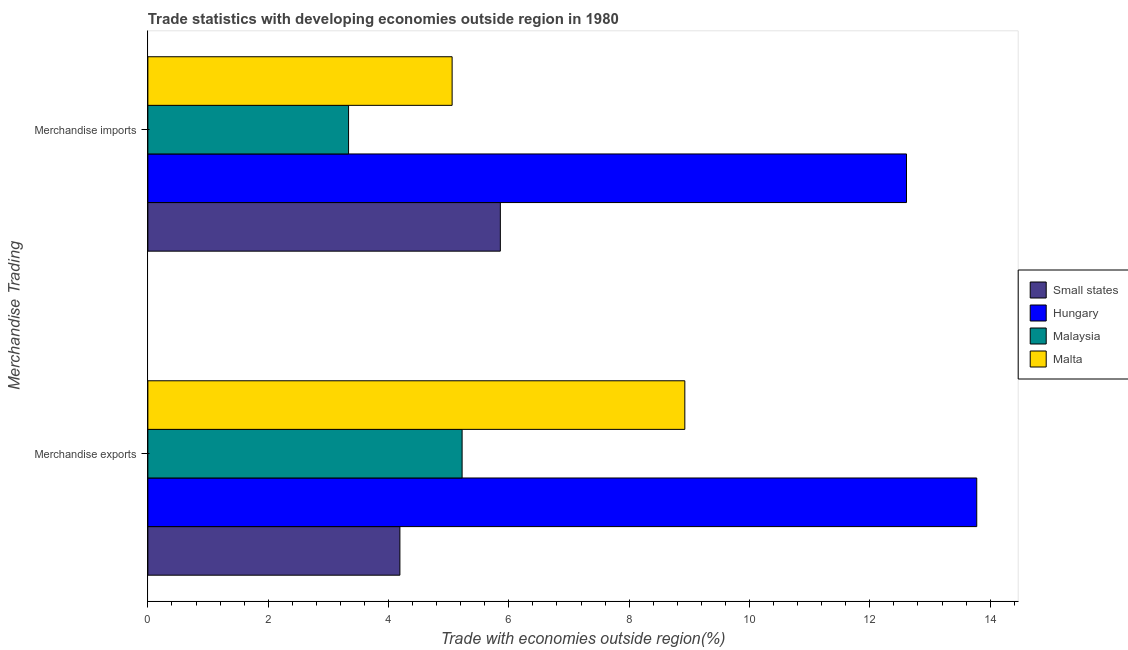How many different coloured bars are there?
Ensure brevity in your answer.  4. What is the merchandise exports in Small states?
Offer a very short reply. 4.19. Across all countries, what is the maximum merchandise imports?
Provide a succinct answer. 12.61. Across all countries, what is the minimum merchandise exports?
Make the answer very short. 4.19. In which country was the merchandise exports maximum?
Keep it short and to the point. Hungary. In which country was the merchandise imports minimum?
Ensure brevity in your answer.  Malaysia. What is the total merchandise imports in the graph?
Keep it short and to the point. 26.86. What is the difference between the merchandise exports in Hungary and that in Small states?
Ensure brevity in your answer.  9.59. What is the difference between the merchandise imports in Hungary and the merchandise exports in Small states?
Give a very brief answer. 8.42. What is the average merchandise imports per country?
Offer a terse response. 6.72. What is the difference between the merchandise imports and merchandise exports in Malta?
Your response must be concise. -3.87. What is the ratio of the merchandise exports in Small states to that in Hungary?
Keep it short and to the point. 0.3. What does the 3rd bar from the top in Merchandise exports represents?
Offer a terse response. Hungary. What does the 4th bar from the bottom in Merchandise imports represents?
Your response must be concise. Malta. How many countries are there in the graph?
Your response must be concise. 4. How many legend labels are there?
Provide a short and direct response. 4. What is the title of the graph?
Make the answer very short. Trade statistics with developing economies outside region in 1980. Does "Kazakhstan" appear as one of the legend labels in the graph?
Offer a terse response. No. What is the label or title of the X-axis?
Your answer should be very brief. Trade with economies outside region(%). What is the label or title of the Y-axis?
Provide a short and direct response. Merchandise Trading. What is the Trade with economies outside region(%) of Small states in Merchandise exports?
Your response must be concise. 4.19. What is the Trade with economies outside region(%) of Hungary in Merchandise exports?
Your answer should be very brief. 13.78. What is the Trade with economies outside region(%) in Malaysia in Merchandise exports?
Provide a short and direct response. 5.22. What is the Trade with economies outside region(%) in Malta in Merchandise exports?
Offer a very short reply. 8.93. What is the Trade with economies outside region(%) in Small states in Merchandise imports?
Offer a terse response. 5.86. What is the Trade with economies outside region(%) in Hungary in Merchandise imports?
Your answer should be compact. 12.61. What is the Trade with economies outside region(%) in Malaysia in Merchandise imports?
Your answer should be very brief. 3.34. What is the Trade with economies outside region(%) in Malta in Merchandise imports?
Offer a very short reply. 5.06. Across all Merchandise Trading, what is the maximum Trade with economies outside region(%) in Small states?
Keep it short and to the point. 5.86. Across all Merchandise Trading, what is the maximum Trade with economies outside region(%) in Hungary?
Provide a short and direct response. 13.78. Across all Merchandise Trading, what is the maximum Trade with economies outside region(%) in Malaysia?
Provide a short and direct response. 5.22. Across all Merchandise Trading, what is the maximum Trade with economies outside region(%) in Malta?
Make the answer very short. 8.93. Across all Merchandise Trading, what is the minimum Trade with economies outside region(%) in Small states?
Ensure brevity in your answer.  4.19. Across all Merchandise Trading, what is the minimum Trade with economies outside region(%) of Hungary?
Offer a very short reply. 12.61. Across all Merchandise Trading, what is the minimum Trade with economies outside region(%) of Malaysia?
Offer a very short reply. 3.34. Across all Merchandise Trading, what is the minimum Trade with economies outside region(%) in Malta?
Offer a terse response. 5.06. What is the total Trade with economies outside region(%) in Small states in the graph?
Ensure brevity in your answer.  10.05. What is the total Trade with economies outside region(%) of Hungary in the graph?
Your response must be concise. 26.39. What is the total Trade with economies outside region(%) in Malaysia in the graph?
Your answer should be compact. 8.56. What is the total Trade with economies outside region(%) of Malta in the graph?
Offer a terse response. 13.98. What is the difference between the Trade with economies outside region(%) in Small states in Merchandise exports and that in Merchandise imports?
Offer a very short reply. -1.67. What is the difference between the Trade with economies outside region(%) in Hungary in Merchandise exports and that in Merchandise imports?
Keep it short and to the point. 1.17. What is the difference between the Trade with economies outside region(%) of Malaysia in Merchandise exports and that in Merchandise imports?
Offer a terse response. 1.89. What is the difference between the Trade with economies outside region(%) in Malta in Merchandise exports and that in Merchandise imports?
Give a very brief answer. 3.87. What is the difference between the Trade with economies outside region(%) in Small states in Merchandise exports and the Trade with economies outside region(%) in Hungary in Merchandise imports?
Offer a terse response. -8.42. What is the difference between the Trade with economies outside region(%) of Small states in Merchandise exports and the Trade with economies outside region(%) of Malaysia in Merchandise imports?
Your answer should be compact. 0.85. What is the difference between the Trade with economies outside region(%) of Small states in Merchandise exports and the Trade with economies outside region(%) of Malta in Merchandise imports?
Your response must be concise. -0.87. What is the difference between the Trade with economies outside region(%) of Hungary in Merchandise exports and the Trade with economies outside region(%) of Malaysia in Merchandise imports?
Your answer should be compact. 10.44. What is the difference between the Trade with economies outside region(%) of Hungary in Merchandise exports and the Trade with economies outside region(%) of Malta in Merchandise imports?
Your answer should be compact. 8.72. What is the difference between the Trade with economies outside region(%) in Malaysia in Merchandise exports and the Trade with economies outside region(%) in Malta in Merchandise imports?
Ensure brevity in your answer.  0.17. What is the average Trade with economies outside region(%) of Small states per Merchandise Trading?
Offer a very short reply. 5.02. What is the average Trade with economies outside region(%) of Hungary per Merchandise Trading?
Offer a very short reply. 13.19. What is the average Trade with economies outside region(%) of Malaysia per Merchandise Trading?
Your answer should be compact. 4.28. What is the average Trade with economies outside region(%) of Malta per Merchandise Trading?
Your response must be concise. 6.99. What is the difference between the Trade with economies outside region(%) in Small states and Trade with economies outside region(%) in Hungary in Merchandise exports?
Provide a short and direct response. -9.59. What is the difference between the Trade with economies outside region(%) of Small states and Trade with economies outside region(%) of Malaysia in Merchandise exports?
Offer a terse response. -1.03. What is the difference between the Trade with economies outside region(%) of Small states and Trade with economies outside region(%) of Malta in Merchandise exports?
Your answer should be very brief. -4.74. What is the difference between the Trade with economies outside region(%) in Hungary and Trade with economies outside region(%) in Malaysia in Merchandise exports?
Make the answer very short. 8.55. What is the difference between the Trade with economies outside region(%) of Hungary and Trade with economies outside region(%) of Malta in Merchandise exports?
Keep it short and to the point. 4.85. What is the difference between the Trade with economies outside region(%) of Malaysia and Trade with economies outside region(%) of Malta in Merchandise exports?
Your answer should be very brief. -3.7. What is the difference between the Trade with economies outside region(%) in Small states and Trade with economies outside region(%) in Hungary in Merchandise imports?
Provide a short and direct response. -6.75. What is the difference between the Trade with economies outside region(%) in Small states and Trade with economies outside region(%) in Malaysia in Merchandise imports?
Give a very brief answer. 2.52. What is the difference between the Trade with economies outside region(%) in Small states and Trade with economies outside region(%) in Malta in Merchandise imports?
Provide a succinct answer. 0.8. What is the difference between the Trade with economies outside region(%) in Hungary and Trade with economies outside region(%) in Malaysia in Merchandise imports?
Your answer should be compact. 9.27. What is the difference between the Trade with economies outside region(%) in Hungary and Trade with economies outside region(%) in Malta in Merchandise imports?
Provide a succinct answer. 7.55. What is the difference between the Trade with economies outside region(%) of Malaysia and Trade with economies outside region(%) of Malta in Merchandise imports?
Offer a terse response. -1.72. What is the ratio of the Trade with economies outside region(%) of Small states in Merchandise exports to that in Merchandise imports?
Offer a very short reply. 0.72. What is the ratio of the Trade with economies outside region(%) in Hungary in Merchandise exports to that in Merchandise imports?
Ensure brevity in your answer.  1.09. What is the ratio of the Trade with economies outside region(%) in Malaysia in Merchandise exports to that in Merchandise imports?
Ensure brevity in your answer.  1.57. What is the ratio of the Trade with economies outside region(%) in Malta in Merchandise exports to that in Merchandise imports?
Make the answer very short. 1.76. What is the difference between the highest and the second highest Trade with economies outside region(%) in Small states?
Your answer should be compact. 1.67. What is the difference between the highest and the second highest Trade with economies outside region(%) in Hungary?
Your answer should be compact. 1.17. What is the difference between the highest and the second highest Trade with economies outside region(%) in Malaysia?
Ensure brevity in your answer.  1.89. What is the difference between the highest and the second highest Trade with economies outside region(%) in Malta?
Your response must be concise. 3.87. What is the difference between the highest and the lowest Trade with economies outside region(%) in Small states?
Your answer should be very brief. 1.67. What is the difference between the highest and the lowest Trade with economies outside region(%) of Hungary?
Provide a short and direct response. 1.17. What is the difference between the highest and the lowest Trade with economies outside region(%) in Malaysia?
Offer a very short reply. 1.89. What is the difference between the highest and the lowest Trade with economies outside region(%) in Malta?
Your answer should be compact. 3.87. 